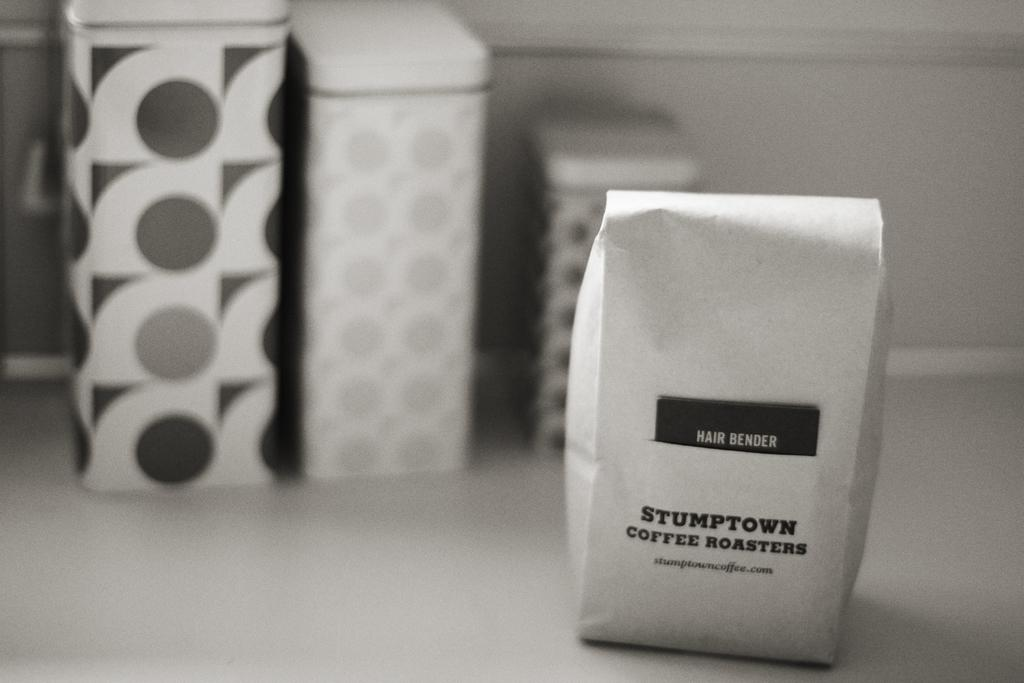<image>
Describe the image concisely. A bag of coffee with the words Stumptown Coffee Roasters. 